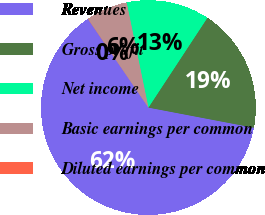Convert chart. <chart><loc_0><loc_0><loc_500><loc_500><pie_chart><fcel>Revenues<fcel>Gross profit<fcel>Net income<fcel>Basic earnings per common<fcel>Diluted earnings per common<nl><fcel>62.46%<fcel>18.75%<fcel>12.51%<fcel>6.26%<fcel>0.02%<nl></chart> 